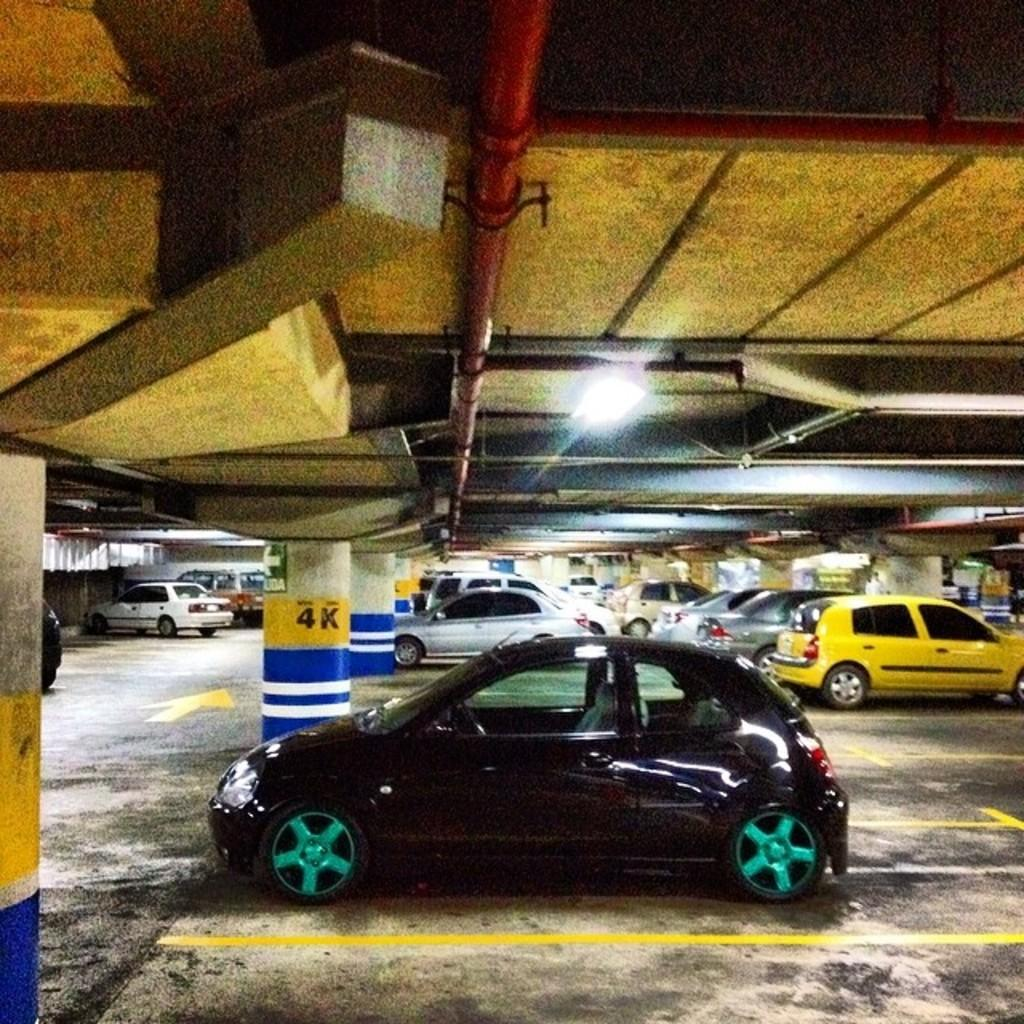<image>
Summarize the visual content of the image. A small number of cars are parked on the 4K level of a parking garage. 